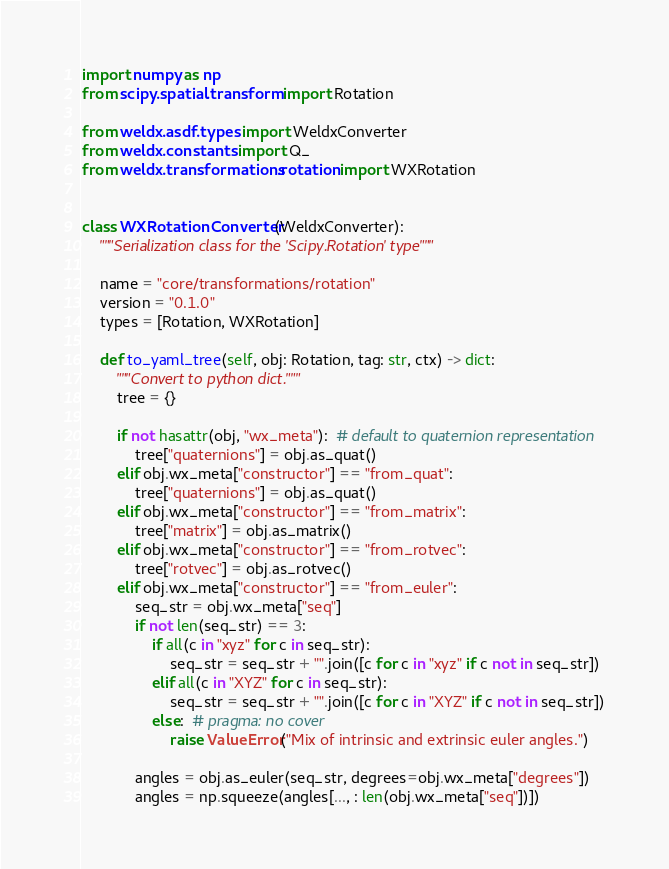Convert code to text. <code><loc_0><loc_0><loc_500><loc_500><_Python_>import numpy as np
from scipy.spatial.transform import Rotation

from weldx.asdf.types import WeldxConverter
from weldx.constants import Q_
from weldx.transformations.rotation import WXRotation


class WXRotationConverter(WeldxConverter):
    """Serialization class for the 'Scipy.Rotation' type"""

    name = "core/transformations/rotation"
    version = "0.1.0"
    types = [Rotation, WXRotation]

    def to_yaml_tree(self, obj: Rotation, tag: str, ctx) -> dict:
        """Convert to python dict."""
        tree = {}

        if not hasattr(obj, "wx_meta"):  # default to quaternion representation
            tree["quaternions"] = obj.as_quat()
        elif obj.wx_meta["constructor"] == "from_quat":
            tree["quaternions"] = obj.as_quat()
        elif obj.wx_meta["constructor"] == "from_matrix":
            tree["matrix"] = obj.as_matrix()
        elif obj.wx_meta["constructor"] == "from_rotvec":
            tree["rotvec"] = obj.as_rotvec()
        elif obj.wx_meta["constructor"] == "from_euler":
            seq_str = obj.wx_meta["seq"]
            if not len(seq_str) == 3:
                if all(c in "xyz" for c in seq_str):
                    seq_str = seq_str + "".join([c for c in "xyz" if c not in seq_str])
                elif all(c in "XYZ" for c in seq_str):
                    seq_str = seq_str + "".join([c for c in "XYZ" if c not in seq_str])
                else:  # pragma: no cover
                    raise ValueError("Mix of intrinsic and extrinsic euler angles.")

            angles = obj.as_euler(seq_str, degrees=obj.wx_meta["degrees"])
            angles = np.squeeze(angles[..., : len(obj.wx_meta["seq"])])
</code> 